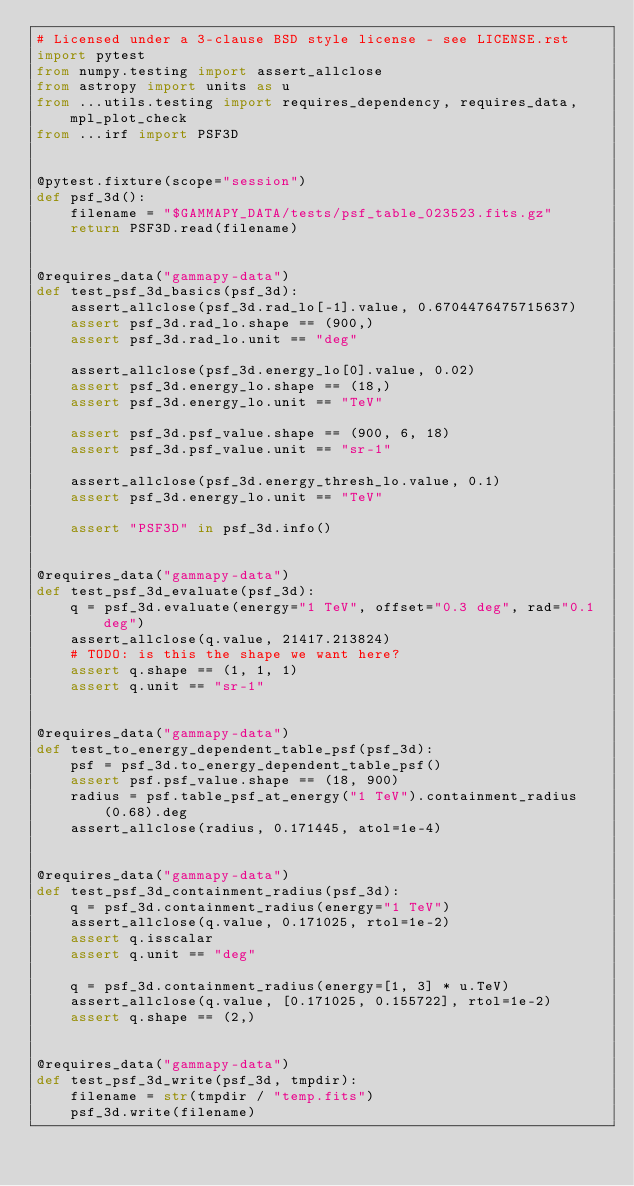<code> <loc_0><loc_0><loc_500><loc_500><_Python_># Licensed under a 3-clause BSD style license - see LICENSE.rst
import pytest
from numpy.testing import assert_allclose
from astropy import units as u
from ...utils.testing import requires_dependency, requires_data, mpl_plot_check
from ...irf import PSF3D


@pytest.fixture(scope="session")
def psf_3d():
    filename = "$GAMMAPY_DATA/tests/psf_table_023523.fits.gz"
    return PSF3D.read(filename)


@requires_data("gammapy-data")
def test_psf_3d_basics(psf_3d):
    assert_allclose(psf_3d.rad_lo[-1].value, 0.6704476475715637)
    assert psf_3d.rad_lo.shape == (900,)
    assert psf_3d.rad_lo.unit == "deg"

    assert_allclose(psf_3d.energy_lo[0].value, 0.02)
    assert psf_3d.energy_lo.shape == (18,)
    assert psf_3d.energy_lo.unit == "TeV"

    assert psf_3d.psf_value.shape == (900, 6, 18)
    assert psf_3d.psf_value.unit == "sr-1"

    assert_allclose(psf_3d.energy_thresh_lo.value, 0.1)
    assert psf_3d.energy_lo.unit == "TeV"

    assert "PSF3D" in psf_3d.info()


@requires_data("gammapy-data")
def test_psf_3d_evaluate(psf_3d):
    q = psf_3d.evaluate(energy="1 TeV", offset="0.3 deg", rad="0.1 deg")
    assert_allclose(q.value, 21417.213824)
    # TODO: is this the shape we want here?
    assert q.shape == (1, 1, 1)
    assert q.unit == "sr-1"


@requires_data("gammapy-data")
def test_to_energy_dependent_table_psf(psf_3d):
    psf = psf_3d.to_energy_dependent_table_psf()
    assert psf.psf_value.shape == (18, 900)
    radius = psf.table_psf_at_energy("1 TeV").containment_radius(0.68).deg
    assert_allclose(radius, 0.171445, atol=1e-4)


@requires_data("gammapy-data")
def test_psf_3d_containment_radius(psf_3d):
    q = psf_3d.containment_radius(energy="1 TeV")
    assert_allclose(q.value, 0.171025, rtol=1e-2)
    assert q.isscalar
    assert q.unit == "deg"

    q = psf_3d.containment_radius(energy=[1, 3] * u.TeV)
    assert_allclose(q.value, [0.171025, 0.155722], rtol=1e-2)
    assert q.shape == (2,)


@requires_data("gammapy-data")
def test_psf_3d_write(psf_3d, tmpdir):
    filename = str(tmpdir / "temp.fits")
    psf_3d.write(filename)</code> 